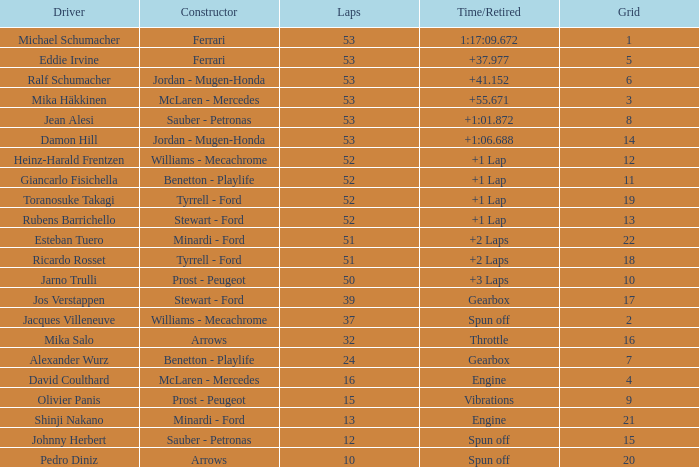What is the maximum lap count for pedro diniz? 10.0. 